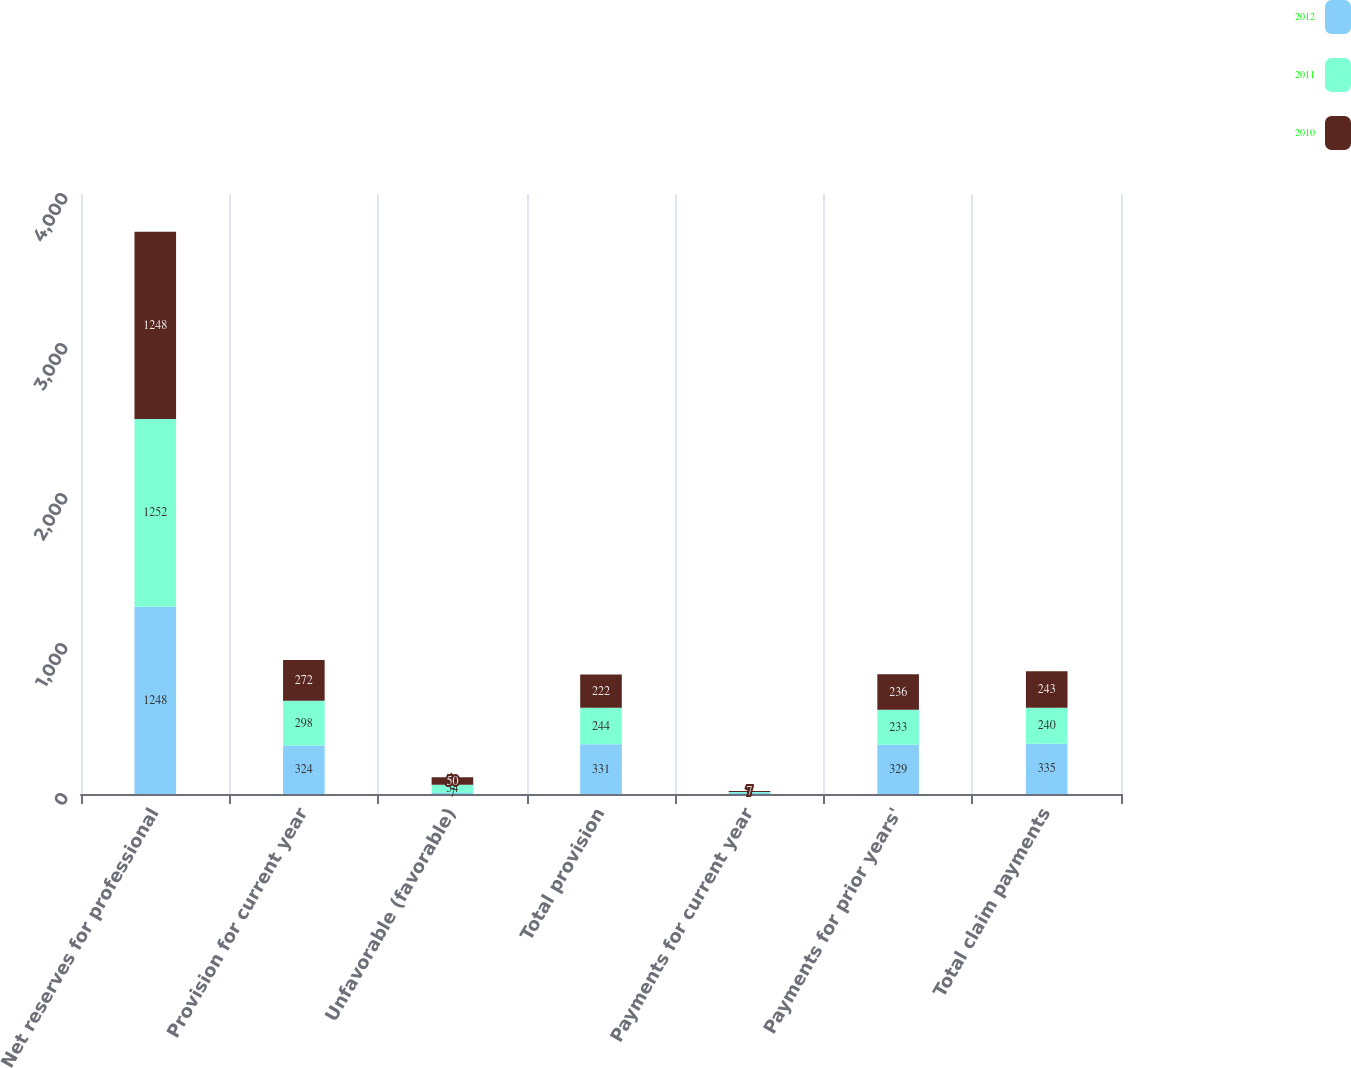Convert chart. <chart><loc_0><loc_0><loc_500><loc_500><stacked_bar_chart><ecel><fcel>Net reserves for professional<fcel>Provision for current year<fcel>Unfavorable (favorable)<fcel>Total provision<fcel>Payments for current year<fcel>Payments for prior years'<fcel>Total claim payments<nl><fcel>2012<fcel>1248<fcel>324<fcel>7<fcel>331<fcel>6<fcel>329<fcel>335<nl><fcel>2011<fcel>1252<fcel>298<fcel>54<fcel>244<fcel>7<fcel>233<fcel>240<nl><fcel>2010<fcel>1248<fcel>272<fcel>50<fcel>222<fcel>7<fcel>236<fcel>243<nl></chart> 